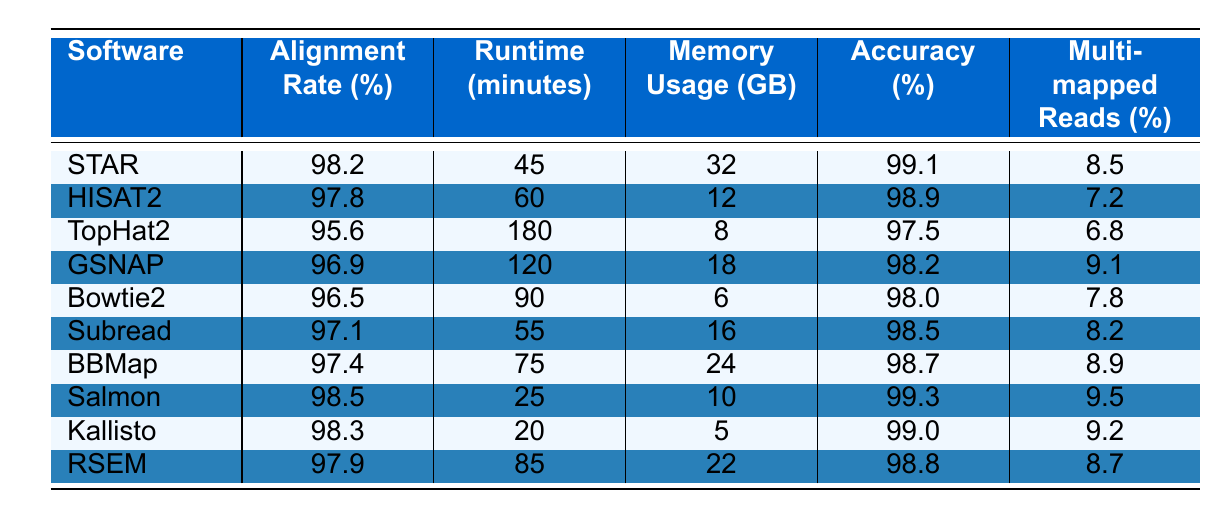What is the alignment rate of STAR? The table lists the alignment rate for each software, and for STAR, it is specified as 98.2%.
Answer: 98.2% Which software has the longest runtime? By comparing all the runtime values in the table, TopHat2 has the longest runtime at 180 minutes.
Answer: TopHat2 What is the average memory usage across all software? To find the average memory usage, sum the memory usage values (32 + 12 + 8 + 18 + 6 + 16 + 24 + 10 + 5 + 22 = 153) and divide by the number of software (10), which gives us 153 / 10 = 15.3 GB.
Answer: 15.3 GB Is the accuracy of Kallisto greater than 99%? The accuracy of Kallisto is listed as 99.0%, which is not greater than 99%.
Answer: No What is the difference in alignment rates between Salmon and Bowtie2? The alignment rate for Salmon is 98.5% and for Bowtie2 is 96.5%. The difference is calculated as 98.5 - 96.5 = 2.0%.
Answer: 2.0% Which software has the highest accuracy and what is its value? By scanning the accuracy values, Salmon shows the highest accuracy at 99.3%.
Answer: Salmon, 99.3% If you combine the multi-mapped reads of Subread and HISAT2, what is the total percentage? The multi-mapped reads for Subread is 8.2% and HISAT2 is 7.2%. Adding these gives 8.2 + 7.2 = 15.4%.
Answer: 15.4% How does the runtime of Kallisto compare to that of STAR? Kallisto's runtime is 20 minutes and STAR's is 45 minutes. Therefore, Kallisto is faster by 45 - 20 = 25 minutes.
Answer: Kallisto is faster by 25 minutes Which software has the lowest memory usage? Comparing the memory usage values, Kallisto has the lowest usage at 5 GB.
Answer: Kallisto What is the relationship between alignment rate and accuracy for HISAT2? The alignment rate for HISAT2 is 97.8% and the accuracy is 98.9%, indicating that a high alignment rate corresponds to a high accuracy in this case.
Answer: Positive correlation 